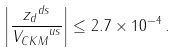Convert formula to latex. <formula><loc_0><loc_0><loc_500><loc_500>\left | \frac { { z _ { d } } ^ { d s } } { { V _ { C K M } } ^ { u s } } \right | \leq 2 . 7 \times 1 0 ^ { - 4 } \, .</formula> 